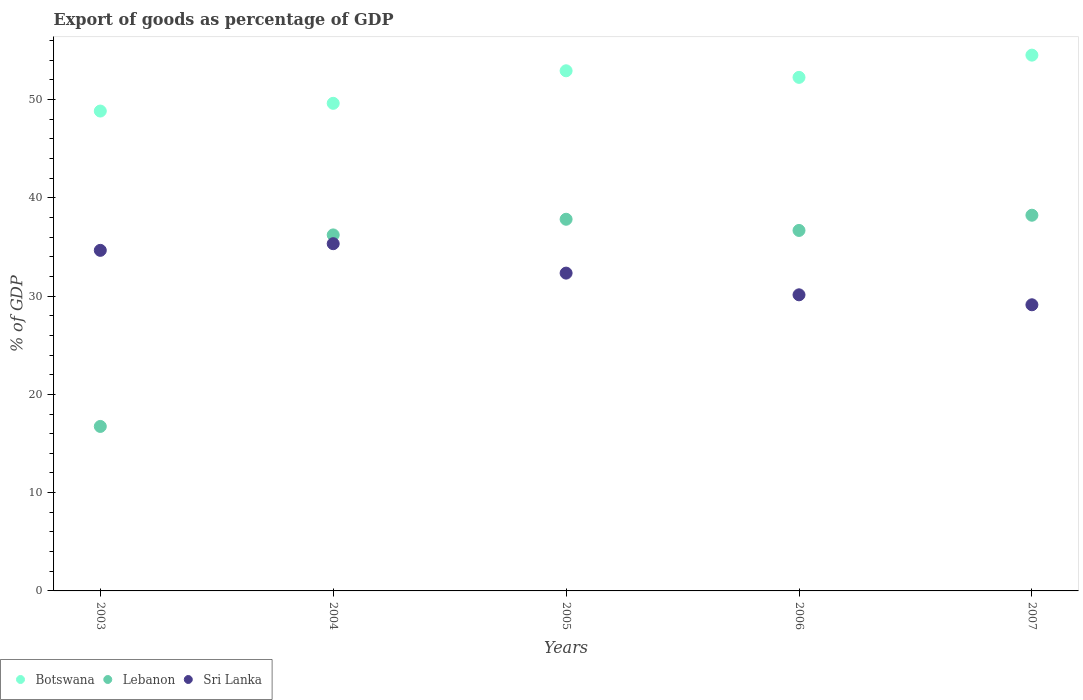How many different coloured dotlines are there?
Give a very brief answer. 3. What is the export of goods as percentage of GDP in Lebanon in 2004?
Keep it short and to the point. 36.22. Across all years, what is the maximum export of goods as percentage of GDP in Botswana?
Your response must be concise. 54.52. Across all years, what is the minimum export of goods as percentage of GDP in Lebanon?
Offer a terse response. 16.74. In which year was the export of goods as percentage of GDP in Botswana maximum?
Your answer should be compact. 2007. In which year was the export of goods as percentage of GDP in Botswana minimum?
Your response must be concise. 2003. What is the total export of goods as percentage of GDP in Sri Lanka in the graph?
Give a very brief answer. 161.56. What is the difference between the export of goods as percentage of GDP in Botswana in 2003 and that in 2004?
Your response must be concise. -0.79. What is the difference between the export of goods as percentage of GDP in Sri Lanka in 2004 and the export of goods as percentage of GDP in Botswana in 2003?
Offer a very short reply. -13.5. What is the average export of goods as percentage of GDP in Botswana per year?
Offer a terse response. 51.63. In the year 2007, what is the difference between the export of goods as percentage of GDP in Sri Lanka and export of goods as percentage of GDP in Botswana?
Your answer should be very brief. -25.4. In how many years, is the export of goods as percentage of GDP in Botswana greater than 38 %?
Make the answer very short. 5. What is the ratio of the export of goods as percentage of GDP in Botswana in 2004 to that in 2006?
Your answer should be compact. 0.95. Is the export of goods as percentage of GDP in Lebanon in 2003 less than that in 2006?
Ensure brevity in your answer.  Yes. Is the difference between the export of goods as percentage of GDP in Sri Lanka in 2005 and 2007 greater than the difference between the export of goods as percentage of GDP in Botswana in 2005 and 2007?
Provide a short and direct response. Yes. What is the difference between the highest and the second highest export of goods as percentage of GDP in Lebanon?
Your response must be concise. 0.41. What is the difference between the highest and the lowest export of goods as percentage of GDP in Sri Lanka?
Give a very brief answer. 6.22. Is the sum of the export of goods as percentage of GDP in Botswana in 2005 and 2006 greater than the maximum export of goods as percentage of GDP in Sri Lanka across all years?
Your answer should be very brief. Yes. Is it the case that in every year, the sum of the export of goods as percentage of GDP in Sri Lanka and export of goods as percentage of GDP in Lebanon  is greater than the export of goods as percentage of GDP in Botswana?
Offer a terse response. Yes. Does the export of goods as percentage of GDP in Lebanon monotonically increase over the years?
Provide a short and direct response. No. Is the export of goods as percentage of GDP in Sri Lanka strictly less than the export of goods as percentage of GDP in Lebanon over the years?
Your answer should be very brief. No. How many dotlines are there?
Your response must be concise. 3. How many years are there in the graph?
Keep it short and to the point. 5. What is the difference between two consecutive major ticks on the Y-axis?
Keep it short and to the point. 10. Does the graph contain grids?
Your answer should be very brief. No. Where does the legend appear in the graph?
Offer a very short reply. Bottom left. How are the legend labels stacked?
Your response must be concise. Horizontal. What is the title of the graph?
Make the answer very short. Export of goods as percentage of GDP. Does "France" appear as one of the legend labels in the graph?
Offer a terse response. No. What is the label or title of the Y-axis?
Give a very brief answer. % of GDP. What is the % of GDP of Botswana in 2003?
Your answer should be very brief. 48.83. What is the % of GDP of Lebanon in 2003?
Offer a very short reply. 16.74. What is the % of GDP of Sri Lanka in 2003?
Offer a very short reply. 34.65. What is the % of GDP in Botswana in 2004?
Offer a very short reply. 49.61. What is the % of GDP of Lebanon in 2004?
Provide a succinct answer. 36.22. What is the % of GDP in Sri Lanka in 2004?
Your answer should be very brief. 35.33. What is the % of GDP in Botswana in 2005?
Offer a very short reply. 52.92. What is the % of GDP of Lebanon in 2005?
Give a very brief answer. 37.82. What is the % of GDP of Sri Lanka in 2005?
Ensure brevity in your answer.  32.34. What is the % of GDP in Botswana in 2006?
Make the answer very short. 52.25. What is the % of GDP of Lebanon in 2006?
Your answer should be very brief. 36.68. What is the % of GDP in Sri Lanka in 2006?
Your answer should be compact. 30.13. What is the % of GDP of Botswana in 2007?
Provide a short and direct response. 54.52. What is the % of GDP in Lebanon in 2007?
Your answer should be very brief. 38.23. What is the % of GDP of Sri Lanka in 2007?
Offer a very short reply. 29.11. Across all years, what is the maximum % of GDP in Botswana?
Provide a short and direct response. 54.52. Across all years, what is the maximum % of GDP of Lebanon?
Give a very brief answer. 38.23. Across all years, what is the maximum % of GDP in Sri Lanka?
Make the answer very short. 35.33. Across all years, what is the minimum % of GDP of Botswana?
Ensure brevity in your answer.  48.83. Across all years, what is the minimum % of GDP in Lebanon?
Your answer should be very brief. 16.74. Across all years, what is the minimum % of GDP in Sri Lanka?
Offer a terse response. 29.11. What is the total % of GDP of Botswana in the graph?
Make the answer very short. 258.13. What is the total % of GDP of Lebanon in the graph?
Ensure brevity in your answer.  165.68. What is the total % of GDP in Sri Lanka in the graph?
Offer a terse response. 161.56. What is the difference between the % of GDP of Botswana in 2003 and that in 2004?
Provide a short and direct response. -0.79. What is the difference between the % of GDP in Lebanon in 2003 and that in 2004?
Offer a very short reply. -19.49. What is the difference between the % of GDP in Sri Lanka in 2003 and that in 2004?
Make the answer very short. -0.68. What is the difference between the % of GDP in Botswana in 2003 and that in 2005?
Your answer should be very brief. -4.1. What is the difference between the % of GDP in Lebanon in 2003 and that in 2005?
Keep it short and to the point. -21.08. What is the difference between the % of GDP in Sri Lanka in 2003 and that in 2005?
Offer a terse response. 2.32. What is the difference between the % of GDP in Botswana in 2003 and that in 2006?
Your answer should be compact. -3.43. What is the difference between the % of GDP in Lebanon in 2003 and that in 2006?
Your response must be concise. -19.94. What is the difference between the % of GDP of Sri Lanka in 2003 and that in 2006?
Provide a short and direct response. 4.53. What is the difference between the % of GDP in Botswana in 2003 and that in 2007?
Your answer should be very brief. -5.69. What is the difference between the % of GDP of Lebanon in 2003 and that in 2007?
Provide a short and direct response. -21.49. What is the difference between the % of GDP of Sri Lanka in 2003 and that in 2007?
Your response must be concise. 5.54. What is the difference between the % of GDP in Botswana in 2004 and that in 2005?
Give a very brief answer. -3.31. What is the difference between the % of GDP of Lebanon in 2004 and that in 2005?
Offer a terse response. -1.59. What is the difference between the % of GDP in Sri Lanka in 2004 and that in 2005?
Ensure brevity in your answer.  2.99. What is the difference between the % of GDP of Botswana in 2004 and that in 2006?
Give a very brief answer. -2.64. What is the difference between the % of GDP in Lebanon in 2004 and that in 2006?
Offer a terse response. -0.46. What is the difference between the % of GDP of Sri Lanka in 2004 and that in 2006?
Offer a very short reply. 5.2. What is the difference between the % of GDP of Botswana in 2004 and that in 2007?
Give a very brief answer. -4.9. What is the difference between the % of GDP in Lebanon in 2004 and that in 2007?
Keep it short and to the point. -2. What is the difference between the % of GDP of Sri Lanka in 2004 and that in 2007?
Your answer should be compact. 6.22. What is the difference between the % of GDP of Botswana in 2005 and that in 2006?
Offer a very short reply. 0.67. What is the difference between the % of GDP in Lebanon in 2005 and that in 2006?
Your answer should be compact. 1.14. What is the difference between the % of GDP in Sri Lanka in 2005 and that in 2006?
Make the answer very short. 2.21. What is the difference between the % of GDP in Botswana in 2005 and that in 2007?
Provide a succinct answer. -1.59. What is the difference between the % of GDP in Lebanon in 2005 and that in 2007?
Your response must be concise. -0.41. What is the difference between the % of GDP of Sri Lanka in 2005 and that in 2007?
Offer a terse response. 3.22. What is the difference between the % of GDP in Botswana in 2006 and that in 2007?
Your response must be concise. -2.26. What is the difference between the % of GDP in Lebanon in 2006 and that in 2007?
Ensure brevity in your answer.  -1.55. What is the difference between the % of GDP of Sri Lanka in 2006 and that in 2007?
Give a very brief answer. 1.01. What is the difference between the % of GDP of Botswana in 2003 and the % of GDP of Lebanon in 2004?
Provide a succinct answer. 12.6. What is the difference between the % of GDP of Botswana in 2003 and the % of GDP of Sri Lanka in 2004?
Offer a terse response. 13.5. What is the difference between the % of GDP in Lebanon in 2003 and the % of GDP in Sri Lanka in 2004?
Make the answer very short. -18.59. What is the difference between the % of GDP of Botswana in 2003 and the % of GDP of Lebanon in 2005?
Make the answer very short. 11.01. What is the difference between the % of GDP of Botswana in 2003 and the % of GDP of Sri Lanka in 2005?
Ensure brevity in your answer.  16.49. What is the difference between the % of GDP of Lebanon in 2003 and the % of GDP of Sri Lanka in 2005?
Keep it short and to the point. -15.6. What is the difference between the % of GDP in Botswana in 2003 and the % of GDP in Lebanon in 2006?
Provide a short and direct response. 12.15. What is the difference between the % of GDP of Botswana in 2003 and the % of GDP of Sri Lanka in 2006?
Your response must be concise. 18.7. What is the difference between the % of GDP of Lebanon in 2003 and the % of GDP of Sri Lanka in 2006?
Offer a terse response. -13.39. What is the difference between the % of GDP of Botswana in 2003 and the % of GDP of Lebanon in 2007?
Provide a short and direct response. 10.6. What is the difference between the % of GDP of Botswana in 2003 and the % of GDP of Sri Lanka in 2007?
Your answer should be compact. 19.71. What is the difference between the % of GDP in Lebanon in 2003 and the % of GDP in Sri Lanka in 2007?
Provide a short and direct response. -12.38. What is the difference between the % of GDP in Botswana in 2004 and the % of GDP in Lebanon in 2005?
Your answer should be compact. 11.8. What is the difference between the % of GDP in Botswana in 2004 and the % of GDP in Sri Lanka in 2005?
Keep it short and to the point. 17.28. What is the difference between the % of GDP in Lebanon in 2004 and the % of GDP in Sri Lanka in 2005?
Ensure brevity in your answer.  3.89. What is the difference between the % of GDP in Botswana in 2004 and the % of GDP in Lebanon in 2006?
Your answer should be very brief. 12.93. What is the difference between the % of GDP in Botswana in 2004 and the % of GDP in Sri Lanka in 2006?
Make the answer very short. 19.49. What is the difference between the % of GDP of Lebanon in 2004 and the % of GDP of Sri Lanka in 2006?
Your response must be concise. 6.09. What is the difference between the % of GDP of Botswana in 2004 and the % of GDP of Lebanon in 2007?
Your response must be concise. 11.39. What is the difference between the % of GDP of Botswana in 2004 and the % of GDP of Sri Lanka in 2007?
Provide a succinct answer. 20.5. What is the difference between the % of GDP of Lebanon in 2004 and the % of GDP of Sri Lanka in 2007?
Your answer should be compact. 7.11. What is the difference between the % of GDP in Botswana in 2005 and the % of GDP in Lebanon in 2006?
Your response must be concise. 16.24. What is the difference between the % of GDP of Botswana in 2005 and the % of GDP of Sri Lanka in 2006?
Ensure brevity in your answer.  22.8. What is the difference between the % of GDP in Lebanon in 2005 and the % of GDP in Sri Lanka in 2006?
Your response must be concise. 7.69. What is the difference between the % of GDP in Botswana in 2005 and the % of GDP in Lebanon in 2007?
Keep it short and to the point. 14.7. What is the difference between the % of GDP of Botswana in 2005 and the % of GDP of Sri Lanka in 2007?
Keep it short and to the point. 23.81. What is the difference between the % of GDP in Lebanon in 2005 and the % of GDP in Sri Lanka in 2007?
Keep it short and to the point. 8.7. What is the difference between the % of GDP of Botswana in 2006 and the % of GDP of Lebanon in 2007?
Give a very brief answer. 14.03. What is the difference between the % of GDP of Botswana in 2006 and the % of GDP of Sri Lanka in 2007?
Ensure brevity in your answer.  23.14. What is the difference between the % of GDP in Lebanon in 2006 and the % of GDP in Sri Lanka in 2007?
Make the answer very short. 7.56. What is the average % of GDP in Botswana per year?
Give a very brief answer. 51.63. What is the average % of GDP of Lebanon per year?
Keep it short and to the point. 33.14. What is the average % of GDP of Sri Lanka per year?
Ensure brevity in your answer.  32.31. In the year 2003, what is the difference between the % of GDP of Botswana and % of GDP of Lebanon?
Your answer should be compact. 32.09. In the year 2003, what is the difference between the % of GDP in Botswana and % of GDP in Sri Lanka?
Keep it short and to the point. 14.17. In the year 2003, what is the difference between the % of GDP in Lebanon and % of GDP in Sri Lanka?
Ensure brevity in your answer.  -17.92. In the year 2004, what is the difference between the % of GDP in Botswana and % of GDP in Lebanon?
Your answer should be compact. 13.39. In the year 2004, what is the difference between the % of GDP in Botswana and % of GDP in Sri Lanka?
Give a very brief answer. 14.28. In the year 2004, what is the difference between the % of GDP in Lebanon and % of GDP in Sri Lanka?
Ensure brevity in your answer.  0.89. In the year 2005, what is the difference between the % of GDP in Botswana and % of GDP in Lebanon?
Give a very brief answer. 15.11. In the year 2005, what is the difference between the % of GDP of Botswana and % of GDP of Sri Lanka?
Your answer should be very brief. 20.59. In the year 2005, what is the difference between the % of GDP in Lebanon and % of GDP in Sri Lanka?
Provide a short and direct response. 5.48. In the year 2006, what is the difference between the % of GDP of Botswana and % of GDP of Lebanon?
Your response must be concise. 15.58. In the year 2006, what is the difference between the % of GDP of Botswana and % of GDP of Sri Lanka?
Provide a succinct answer. 22.13. In the year 2006, what is the difference between the % of GDP of Lebanon and % of GDP of Sri Lanka?
Provide a succinct answer. 6.55. In the year 2007, what is the difference between the % of GDP in Botswana and % of GDP in Lebanon?
Your answer should be very brief. 16.29. In the year 2007, what is the difference between the % of GDP of Botswana and % of GDP of Sri Lanka?
Your answer should be compact. 25.4. In the year 2007, what is the difference between the % of GDP in Lebanon and % of GDP in Sri Lanka?
Offer a very short reply. 9.11. What is the ratio of the % of GDP in Botswana in 2003 to that in 2004?
Make the answer very short. 0.98. What is the ratio of the % of GDP in Lebanon in 2003 to that in 2004?
Your answer should be compact. 0.46. What is the ratio of the % of GDP in Sri Lanka in 2003 to that in 2004?
Provide a succinct answer. 0.98. What is the ratio of the % of GDP in Botswana in 2003 to that in 2005?
Provide a succinct answer. 0.92. What is the ratio of the % of GDP of Lebanon in 2003 to that in 2005?
Your response must be concise. 0.44. What is the ratio of the % of GDP of Sri Lanka in 2003 to that in 2005?
Give a very brief answer. 1.07. What is the ratio of the % of GDP of Botswana in 2003 to that in 2006?
Your answer should be very brief. 0.93. What is the ratio of the % of GDP in Lebanon in 2003 to that in 2006?
Give a very brief answer. 0.46. What is the ratio of the % of GDP of Sri Lanka in 2003 to that in 2006?
Offer a terse response. 1.15. What is the ratio of the % of GDP of Botswana in 2003 to that in 2007?
Make the answer very short. 0.9. What is the ratio of the % of GDP in Lebanon in 2003 to that in 2007?
Make the answer very short. 0.44. What is the ratio of the % of GDP in Sri Lanka in 2003 to that in 2007?
Keep it short and to the point. 1.19. What is the ratio of the % of GDP in Lebanon in 2004 to that in 2005?
Your response must be concise. 0.96. What is the ratio of the % of GDP of Sri Lanka in 2004 to that in 2005?
Your answer should be compact. 1.09. What is the ratio of the % of GDP of Botswana in 2004 to that in 2006?
Your answer should be very brief. 0.95. What is the ratio of the % of GDP in Lebanon in 2004 to that in 2006?
Your answer should be very brief. 0.99. What is the ratio of the % of GDP in Sri Lanka in 2004 to that in 2006?
Offer a very short reply. 1.17. What is the ratio of the % of GDP in Botswana in 2004 to that in 2007?
Your response must be concise. 0.91. What is the ratio of the % of GDP in Lebanon in 2004 to that in 2007?
Your response must be concise. 0.95. What is the ratio of the % of GDP in Sri Lanka in 2004 to that in 2007?
Ensure brevity in your answer.  1.21. What is the ratio of the % of GDP in Botswana in 2005 to that in 2006?
Your answer should be very brief. 1.01. What is the ratio of the % of GDP of Lebanon in 2005 to that in 2006?
Make the answer very short. 1.03. What is the ratio of the % of GDP in Sri Lanka in 2005 to that in 2006?
Ensure brevity in your answer.  1.07. What is the ratio of the % of GDP in Botswana in 2005 to that in 2007?
Your answer should be very brief. 0.97. What is the ratio of the % of GDP of Lebanon in 2005 to that in 2007?
Give a very brief answer. 0.99. What is the ratio of the % of GDP in Sri Lanka in 2005 to that in 2007?
Offer a very short reply. 1.11. What is the ratio of the % of GDP of Botswana in 2006 to that in 2007?
Provide a short and direct response. 0.96. What is the ratio of the % of GDP of Lebanon in 2006 to that in 2007?
Provide a succinct answer. 0.96. What is the ratio of the % of GDP in Sri Lanka in 2006 to that in 2007?
Keep it short and to the point. 1.03. What is the difference between the highest and the second highest % of GDP in Botswana?
Offer a very short reply. 1.59. What is the difference between the highest and the second highest % of GDP of Lebanon?
Ensure brevity in your answer.  0.41. What is the difference between the highest and the second highest % of GDP of Sri Lanka?
Provide a succinct answer. 0.68. What is the difference between the highest and the lowest % of GDP in Botswana?
Provide a succinct answer. 5.69. What is the difference between the highest and the lowest % of GDP in Lebanon?
Your response must be concise. 21.49. What is the difference between the highest and the lowest % of GDP of Sri Lanka?
Give a very brief answer. 6.22. 